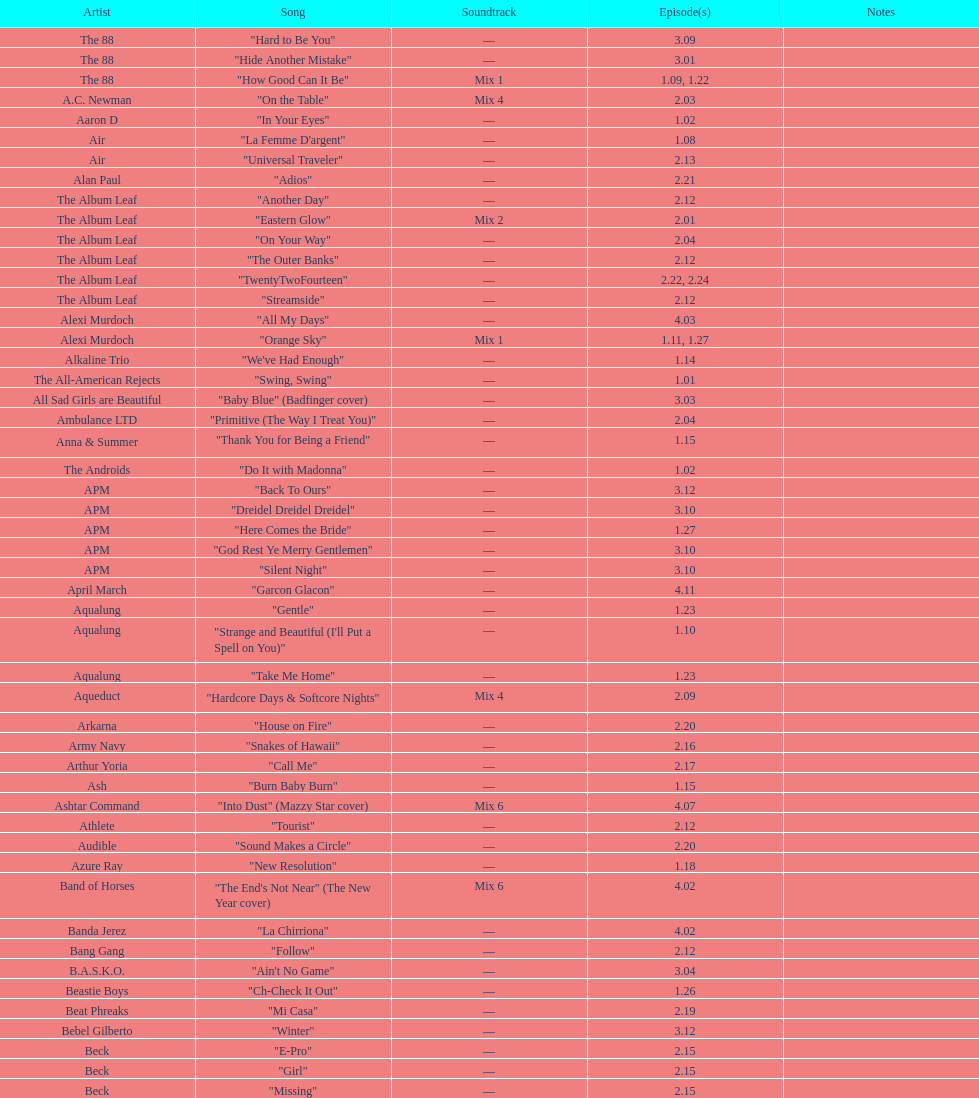The artist ash had only one piece of music showcased in the o.c. what is the name of that piece? "Burn Baby Burn". 